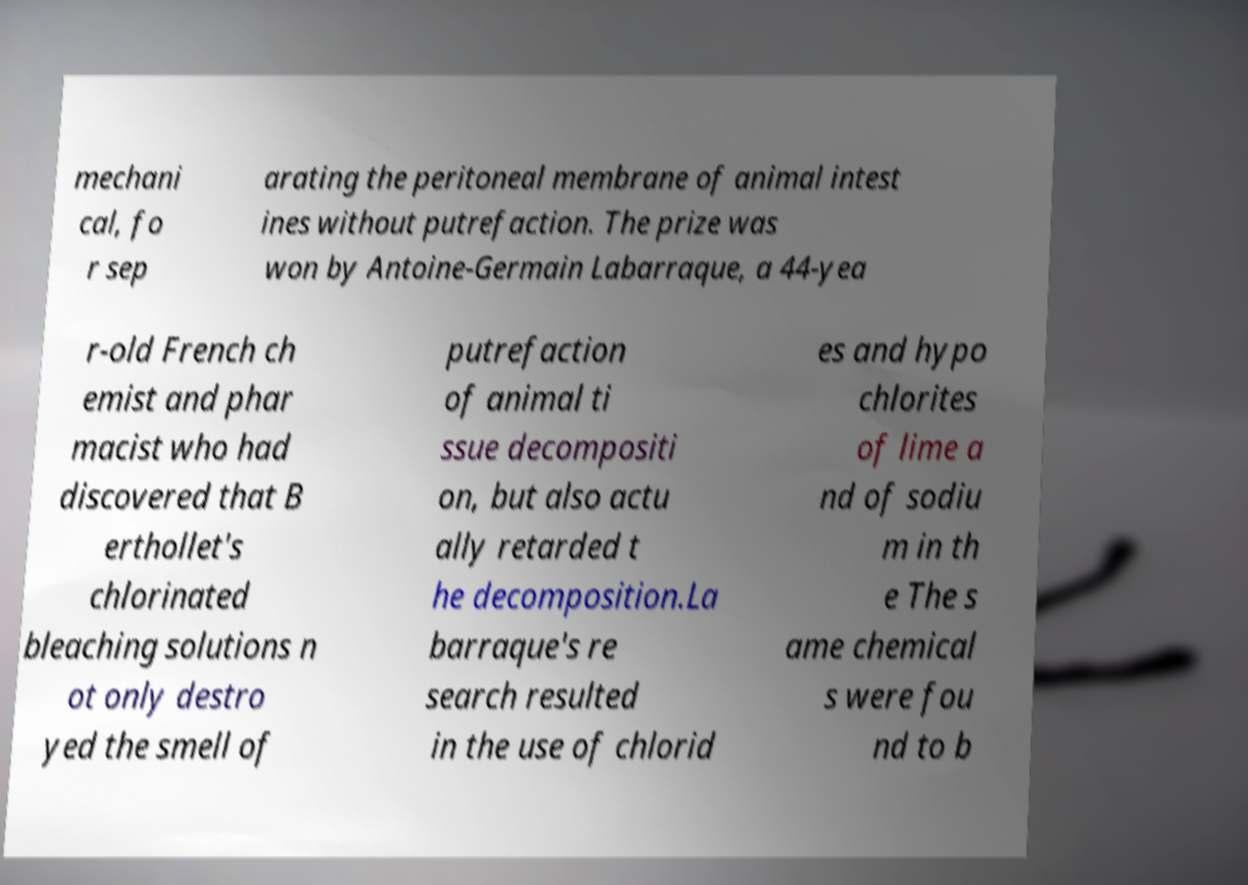Could you assist in decoding the text presented in this image and type it out clearly? mechani cal, fo r sep arating the peritoneal membrane of animal intest ines without putrefaction. The prize was won by Antoine-Germain Labarraque, a 44-yea r-old French ch emist and phar macist who had discovered that B erthollet's chlorinated bleaching solutions n ot only destro yed the smell of putrefaction of animal ti ssue decompositi on, but also actu ally retarded t he decomposition.La barraque's re search resulted in the use of chlorid es and hypo chlorites of lime a nd of sodiu m in th e The s ame chemical s were fou nd to b 